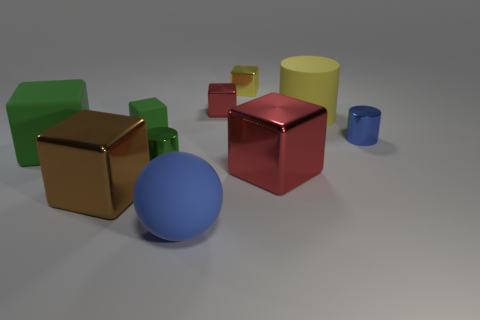Is there anything else that is the same shape as the blue matte object?
Offer a terse response. No. There is a small blue thing; are there any big cylinders left of it?
Your answer should be compact. Yes. Is the ball the same size as the brown thing?
Keep it short and to the point. Yes. The green matte thing that is in front of the tiny green rubber block has what shape?
Your answer should be compact. Cube. Are there any blue shiny cylinders that have the same size as the matte cylinder?
Provide a short and direct response. No. There is a blue ball that is the same size as the yellow matte object; what is it made of?
Provide a short and direct response. Rubber. What size is the matte thing in front of the large green thing?
Give a very brief answer. Large. What size is the yellow rubber object?
Offer a terse response. Large. There is a brown object; does it have the same size as the metal cylinder that is to the left of the tiny yellow metallic object?
Offer a terse response. No. The big metal thing to the left of the green thing that is behind the large green cube is what color?
Your answer should be very brief. Brown. 